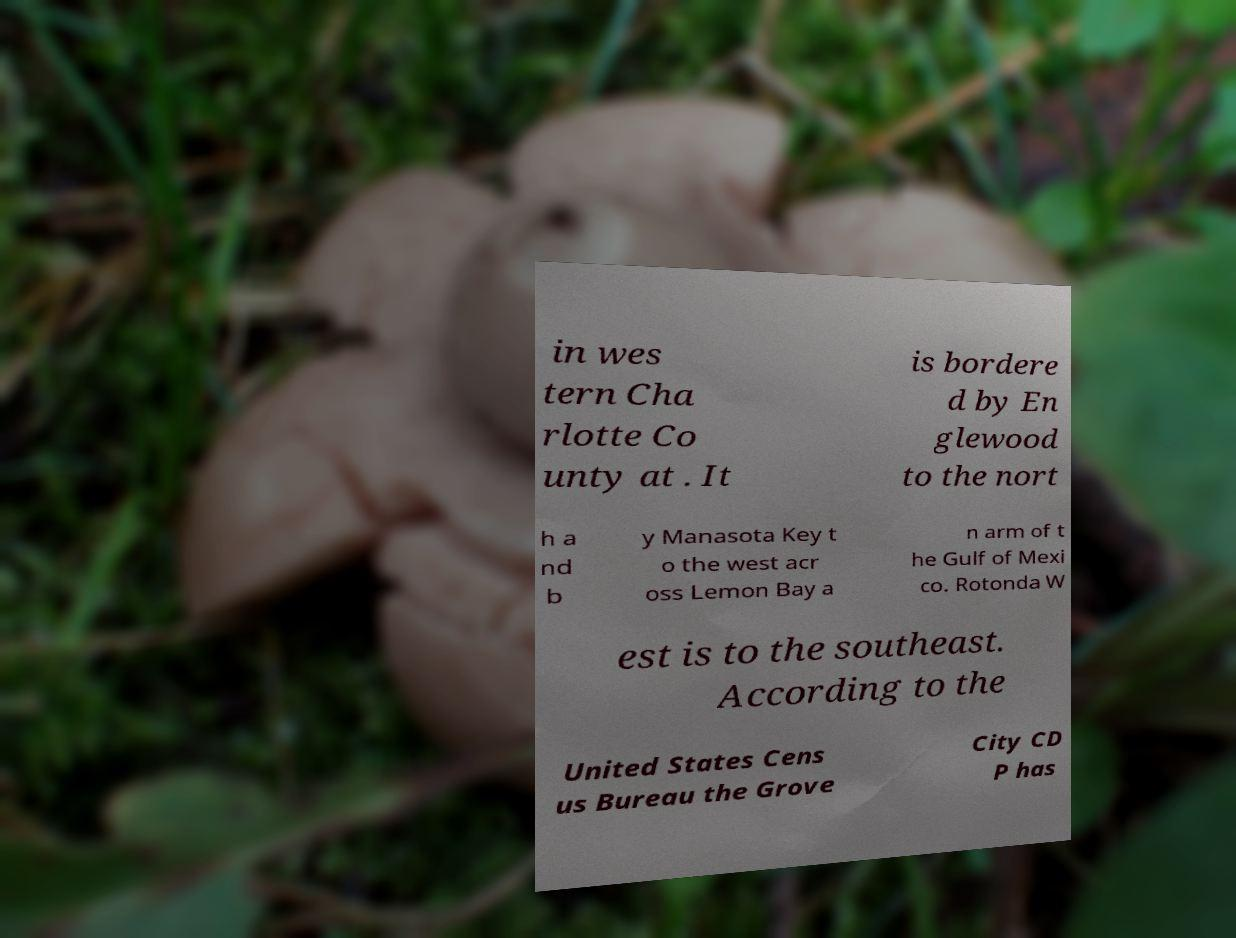I need the written content from this picture converted into text. Can you do that? in wes tern Cha rlotte Co unty at . It is bordere d by En glewood to the nort h a nd b y Manasota Key t o the west acr oss Lemon Bay a n arm of t he Gulf of Mexi co. Rotonda W est is to the southeast. According to the United States Cens us Bureau the Grove City CD P has 